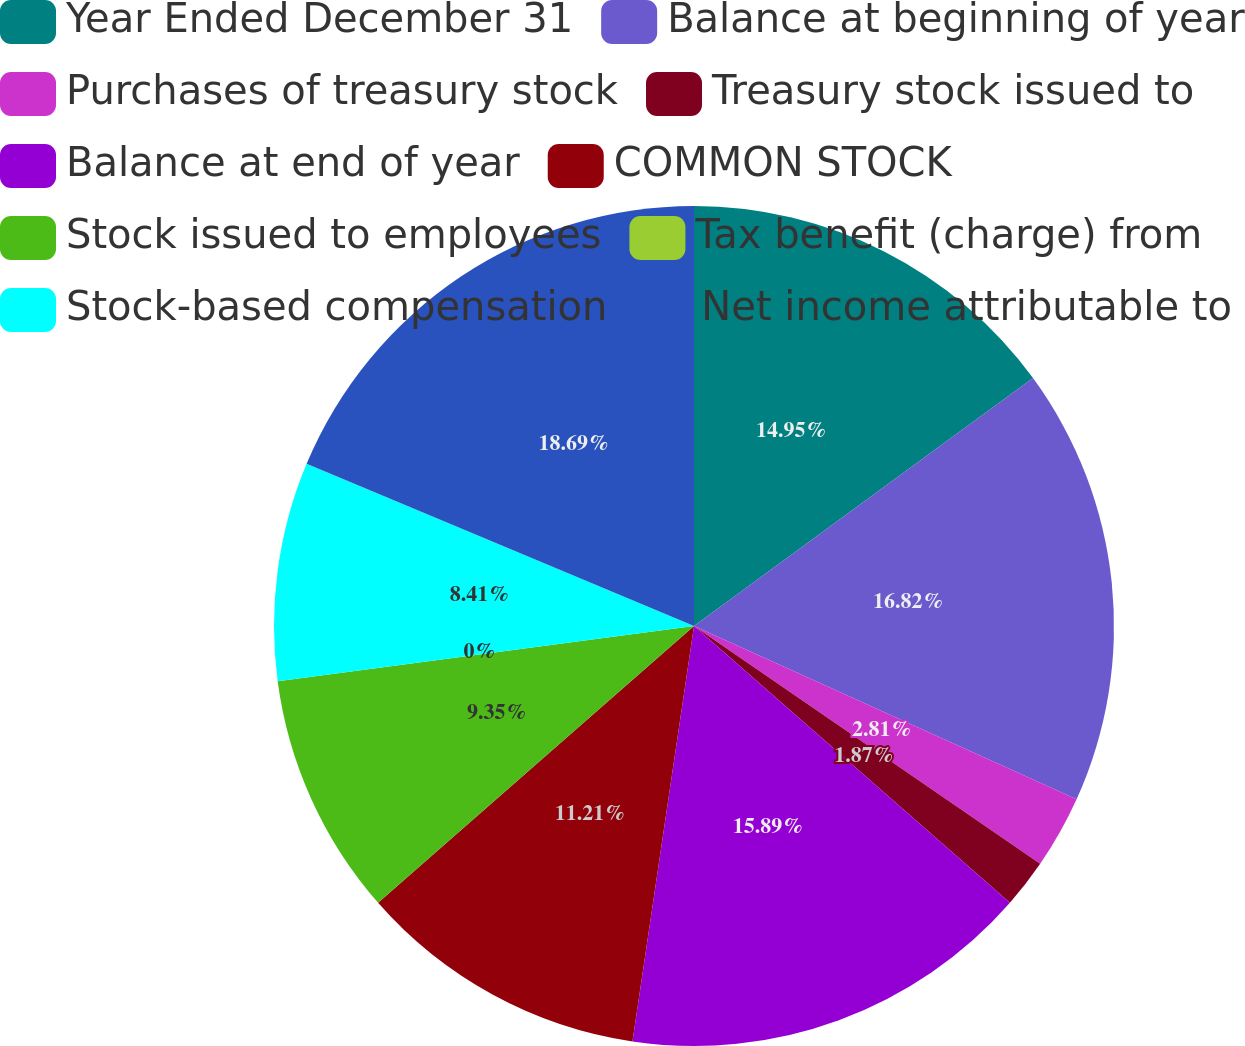Convert chart to OTSL. <chart><loc_0><loc_0><loc_500><loc_500><pie_chart><fcel>Year Ended December 31<fcel>Balance at beginning of year<fcel>Purchases of treasury stock<fcel>Treasury stock issued to<fcel>Balance at end of year<fcel>COMMON STOCK<fcel>Stock issued to employees<fcel>Tax benefit (charge) from<fcel>Stock-based compensation<fcel>Net income attributable to<nl><fcel>14.95%<fcel>16.82%<fcel>2.81%<fcel>1.87%<fcel>15.89%<fcel>11.21%<fcel>9.35%<fcel>0.0%<fcel>8.41%<fcel>18.69%<nl></chart> 